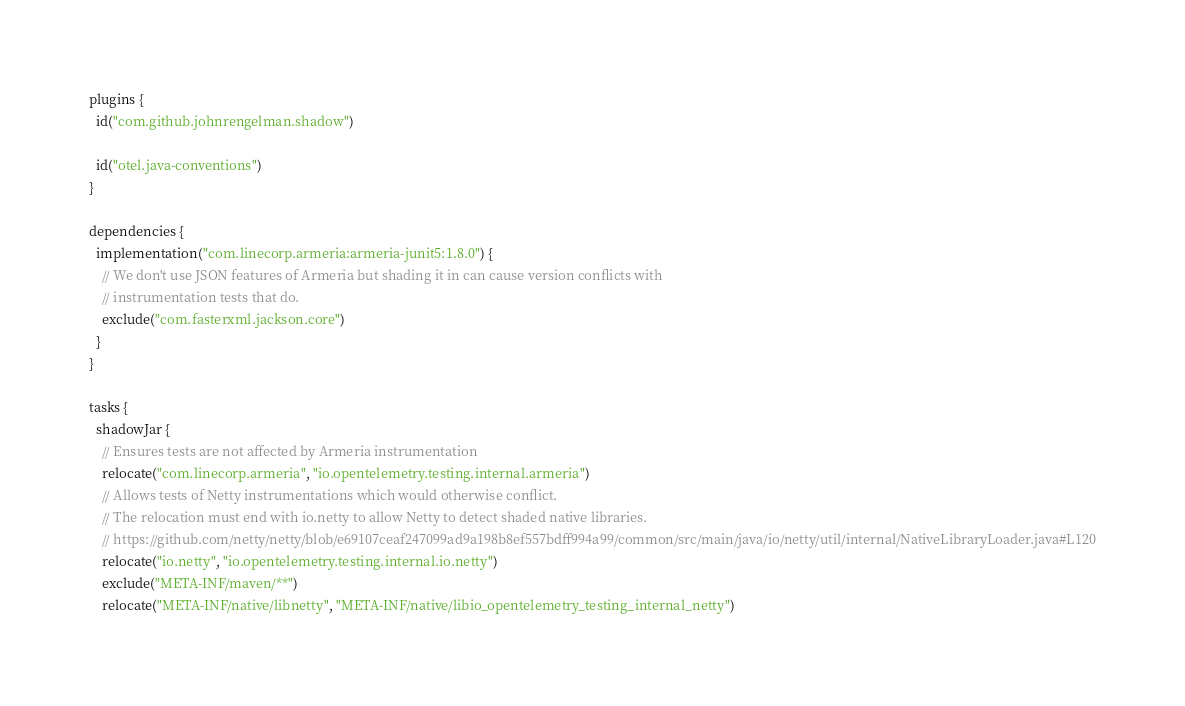<code> <loc_0><loc_0><loc_500><loc_500><_Kotlin_>plugins {
  id("com.github.johnrengelman.shadow")

  id("otel.java-conventions")
}

dependencies {
  implementation("com.linecorp.armeria:armeria-junit5:1.8.0") {
    // We don't use JSON features of Armeria but shading it in can cause version conflicts with
    // instrumentation tests that do.
    exclude("com.fasterxml.jackson.core")
  }
}

tasks {
  shadowJar {
    // Ensures tests are not affected by Armeria instrumentation
    relocate("com.linecorp.armeria", "io.opentelemetry.testing.internal.armeria")
    // Allows tests of Netty instrumentations which would otherwise conflict.
    // The relocation must end with io.netty to allow Netty to detect shaded native libraries.
    // https://github.com/netty/netty/blob/e69107ceaf247099ad9a198b8ef557bdff994a99/common/src/main/java/io/netty/util/internal/NativeLibraryLoader.java#L120
    relocate("io.netty", "io.opentelemetry.testing.internal.io.netty")
    exclude("META-INF/maven/**")
    relocate("META-INF/native/libnetty", "META-INF/native/libio_opentelemetry_testing_internal_netty")</code> 